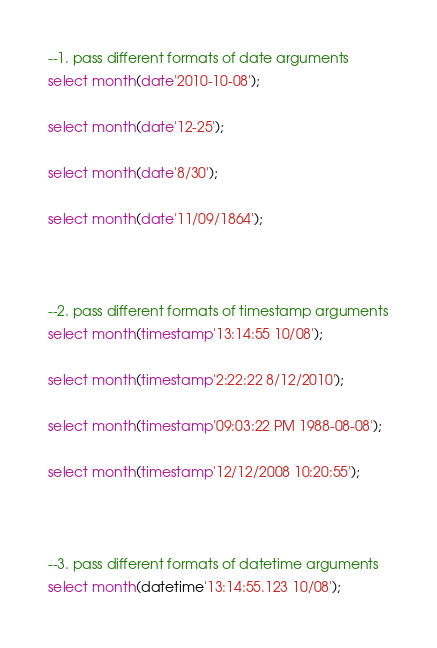<code> <loc_0><loc_0><loc_500><loc_500><_SQL_>
--1. pass different formats of date arguments
select month(date'2010-10-08');

select month(date'12-25');

select month(date'8/30');

select month(date'11/09/1864');



--2. pass different formats of timestamp arguments
select month(timestamp'13:14:55 10/08');

select month(timestamp'2:22:22 8/12/2010');

select month(timestamp'09:03:22 PM 1988-08-08');

select month(timestamp'12/12/2008 10:20:55');



--3. pass different formats of datetime arguments
select month(datetime'13:14:55.123 10/08');
</code> 